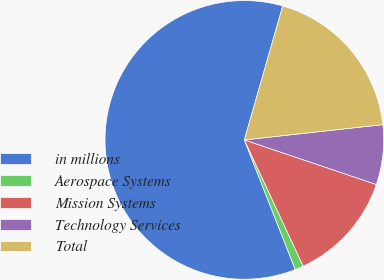<chart> <loc_0><loc_0><loc_500><loc_500><pie_chart><fcel>in millions<fcel>Aerospace Systems<fcel>Mission Systems<fcel>Technology Services<fcel>Total<nl><fcel>60.4%<fcel>0.99%<fcel>12.87%<fcel>6.93%<fcel>18.81%<nl></chart> 